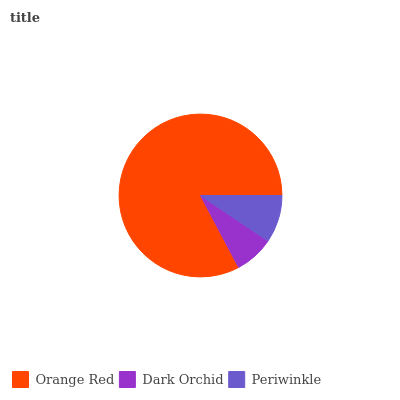Is Dark Orchid the minimum?
Answer yes or no. Yes. Is Orange Red the maximum?
Answer yes or no. Yes. Is Periwinkle the minimum?
Answer yes or no. No. Is Periwinkle the maximum?
Answer yes or no. No. Is Periwinkle greater than Dark Orchid?
Answer yes or no. Yes. Is Dark Orchid less than Periwinkle?
Answer yes or no. Yes. Is Dark Orchid greater than Periwinkle?
Answer yes or no. No. Is Periwinkle less than Dark Orchid?
Answer yes or no. No. Is Periwinkle the high median?
Answer yes or no. Yes. Is Periwinkle the low median?
Answer yes or no. Yes. Is Dark Orchid the high median?
Answer yes or no. No. Is Dark Orchid the low median?
Answer yes or no. No. 